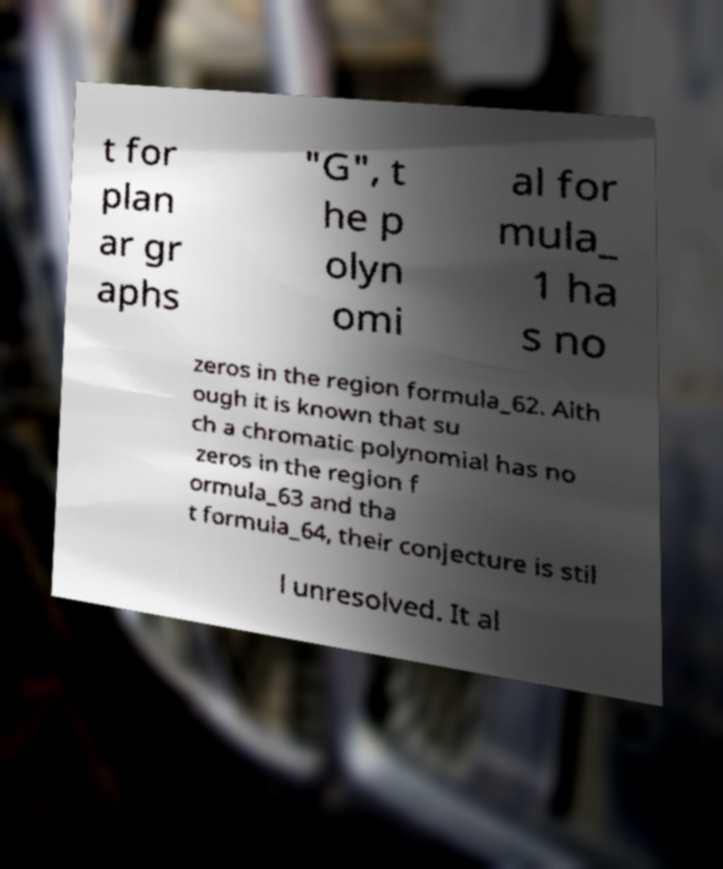Could you extract and type out the text from this image? t for plan ar gr aphs "G", t he p olyn omi al for mula_ 1 ha s no zeros in the region formula_62. Alth ough it is known that su ch a chromatic polynomial has no zeros in the region f ormula_63 and tha t formula_64, their conjecture is stil l unresolved. It al 